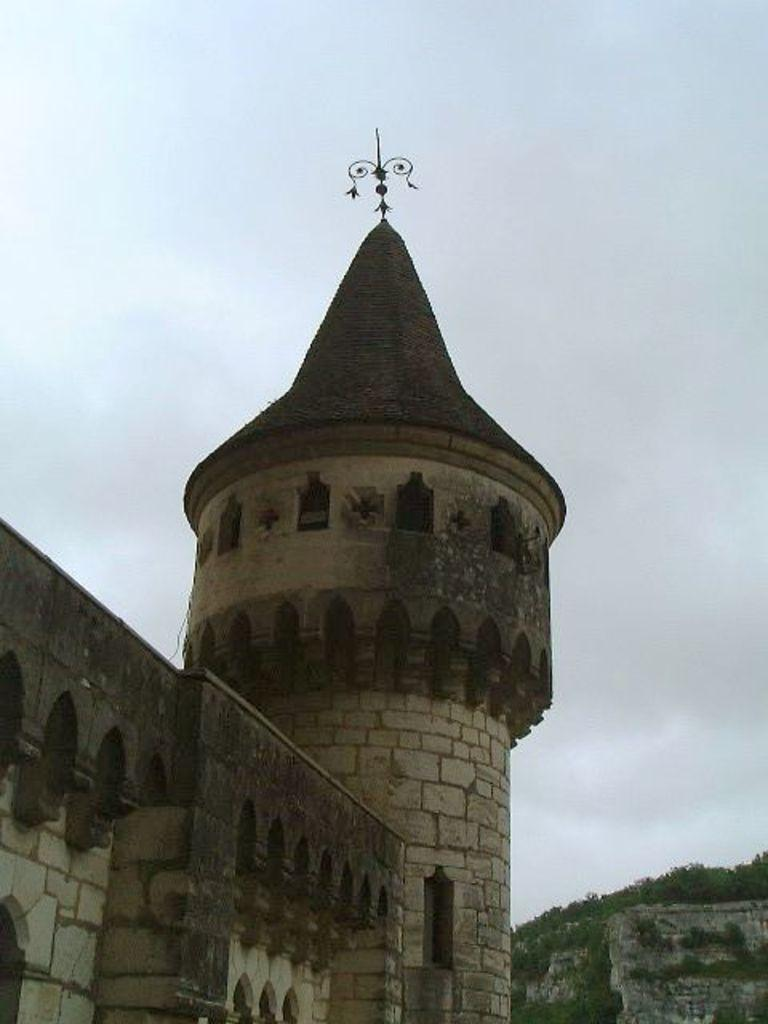What type of structure is present in the image? There is a building in the image. What else can be seen in the image besides the building? There are many plants in the image. What part of the natural environment is visible in the image? The sky is visible in the image. What word is being spelled out by the destruction in the image? There is no destruction present in the image, and therefore no word can be spelled out by it. 